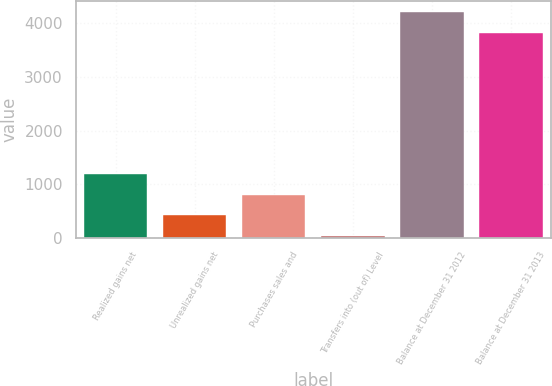<chart> <loc_0><loc_0><loc_500><loc_500><bar_chart><fcel>Realized gains net<fcel>Unrealized gains net<fcel>Purchases sales and<fcel>Transfers into (out of) Level<fcel>Balance at December 31 2012<fcel>Balance at December 31 2013<nl><fcel>1190.2<fcel>415.4<fcel>802.8<fcel>28<fcel>4210.4<fcel>3823<nl></chart> 